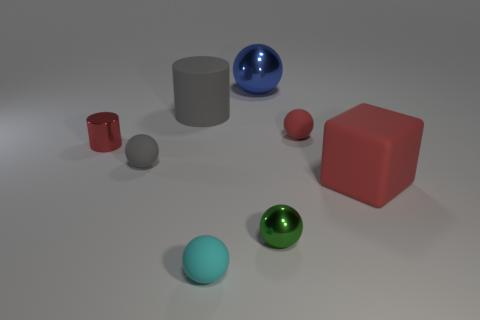Which objects seem to have the smoothest texture? The shiny blue and green spheres exhibit the smoothest textures due to their reflective surfaces. The gray cylinders also appear smooth but with a matte finish. Is there any object that stands out due to its size? Yes, the red cube stands out because it's the largest object in the image, distinct from the other smaller shapes. 